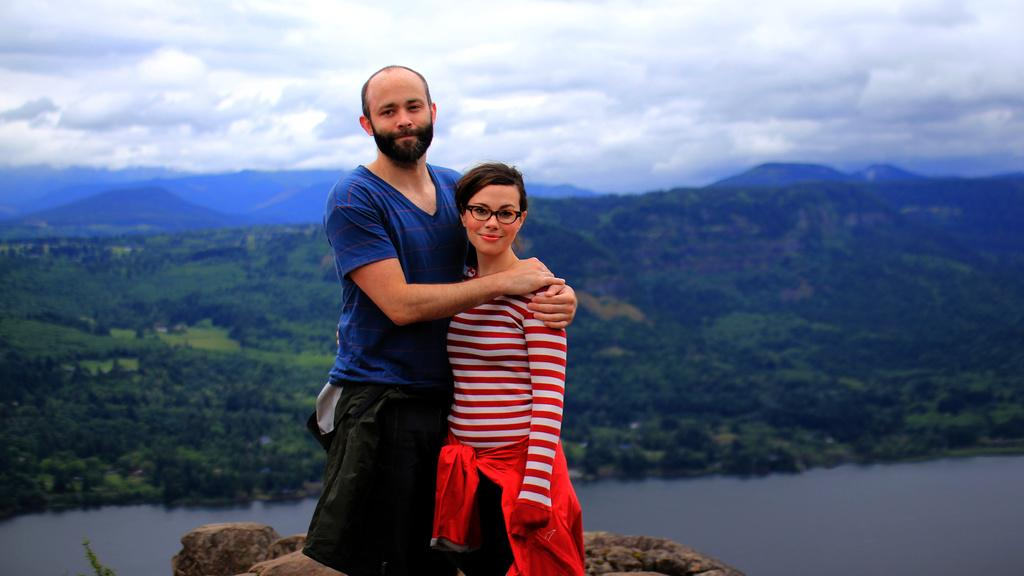Who can be seen in the image? There is a man and a lady in the image. What are the man and the lady doing in the image? They are standing on rocks and posing for a photograph. What can be seen in the background of the image? There is a lake, mountains, trees, and the sky visible in the background of the image. Can you see any spots on the lady's dress in the image? There is no mention of spots on the lady's dress in the provided facts, so it cannot be determined from the image. Is there a cemetery visible in the image? There is no mention of a cemetery in the provided facts, and none can be seen in the image. 